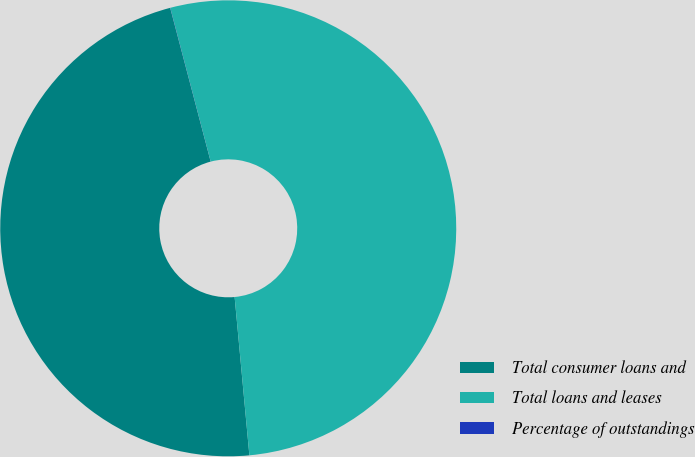<chart> <loc_0><loc_0><loc_500><loc_500><pie_chart><fcel>Total consumer loans and<fcel>Total loans and leases<fcel>Percentage of outstandings<nl><fcel>47.38%<fcel>52.61%<fcel>0.01%<nl></chart> 